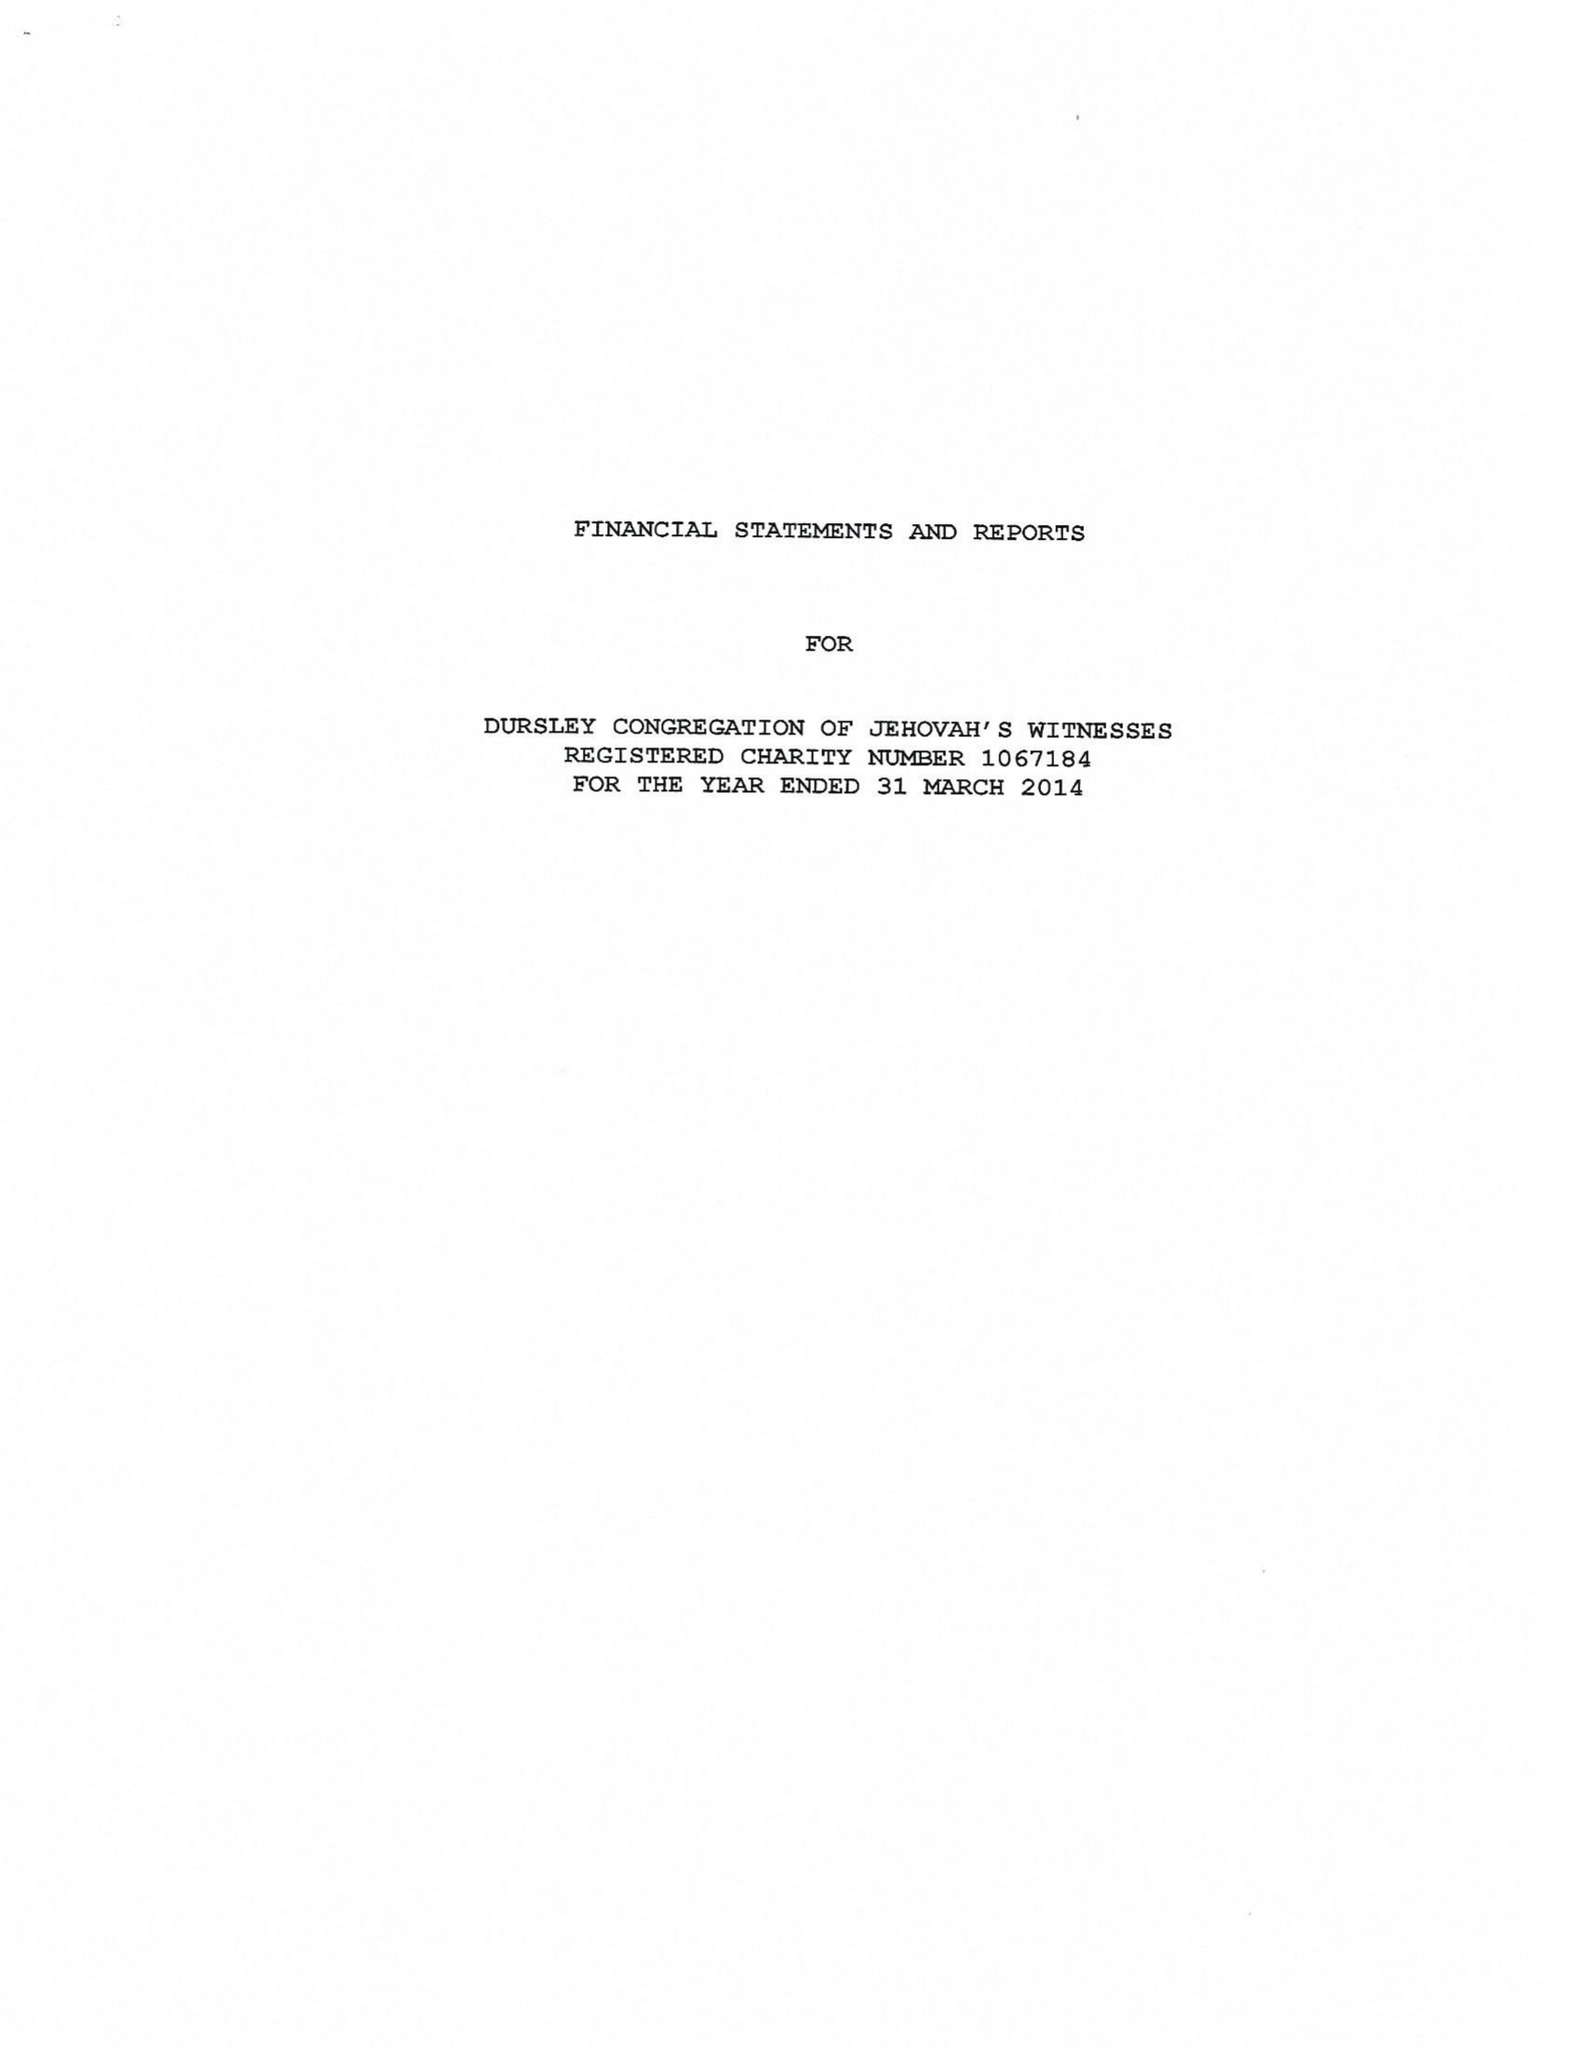What is the value for the address__postcode?
Answer the question using a single word or phrase. GL11 4JB 